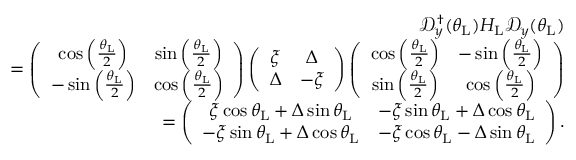Convert formula to latex. <formula><loc_0><loc_0><loc_500><loc_500>\begin{array} { r l r } & { \mathcal { D } _ { y } ^ { \dagger } ( \theta _ { L } ) H _ { L } \mathcal { D } _ { y } ( \theta _ { L } ) } \\ & { = \left ( \begin{array} { c c } { \cos \left ( \frac { \theta _ { L } } { 2 } \right ) } & { \sin \left ( \frac { \theta _ { L } } { 2 } \right ) } \\ { - \sin \left ( \frac { \theta _ { L } } { 2 } \right ) } & { \cos \left ( \frac { \theta _ { L } } { 2 } \right ) } \end{array} \right ) \left ( \begin{array} { c c } { \xi } & { \Delta } \\ { \Delta } & { - \xi } \end{array} \right ) \left ( \begin{array} { c c } { \cos \left ( \frac { \theta _ { L } } { 2 } \right ) } & { - \sin \left ( \frac { \theta _ { L } } { 2 } \right ) } \\ { \sin \left ( \frac { \theta _ { L } } { 2 } \right ) } & { \cos \left ( \frac { \theta _ { L } } { 2 } \right ) } \end{array} \right ) } \\ & { = \left ( \begin{array} { c c } { \xi \cos \theta _ { L } + \Delta \sin \theta _ { L } } & { - \xi \sin \theta _ { L } + \Delta \cos \theta _ { L } } \\ { - \xi \sin \theta _ { L } + \Delta \cos \theta _ { L } } & { - \xi \cos \theta _ { L } - \Delta \sin \theta _ { L } } \end{array} \right ) . } \end{array}</formula> 